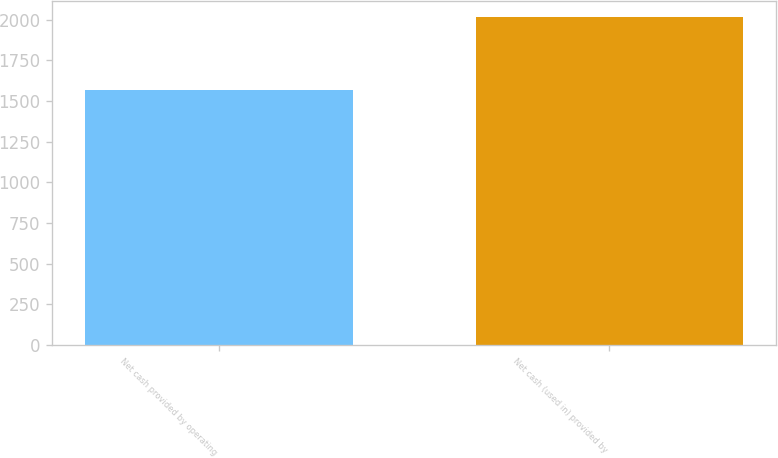<chart> <loc_0><loc_0><loc_500><loc_500><bar_chart><fcel>Net cash provided by operating<fcel>Net cash (used in) provided by<nl><fcel>1567<fcel>2014<nl></chart> 